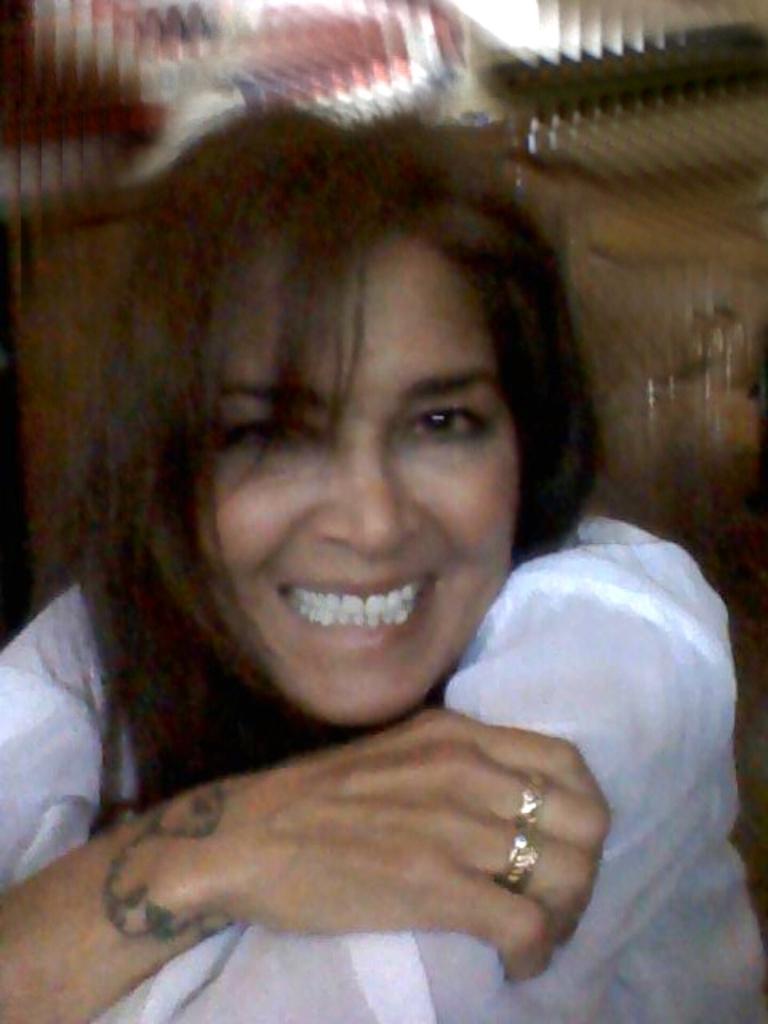Please provide a concise description of this image. As we can see in the image there is a woman wearing white color dress. 